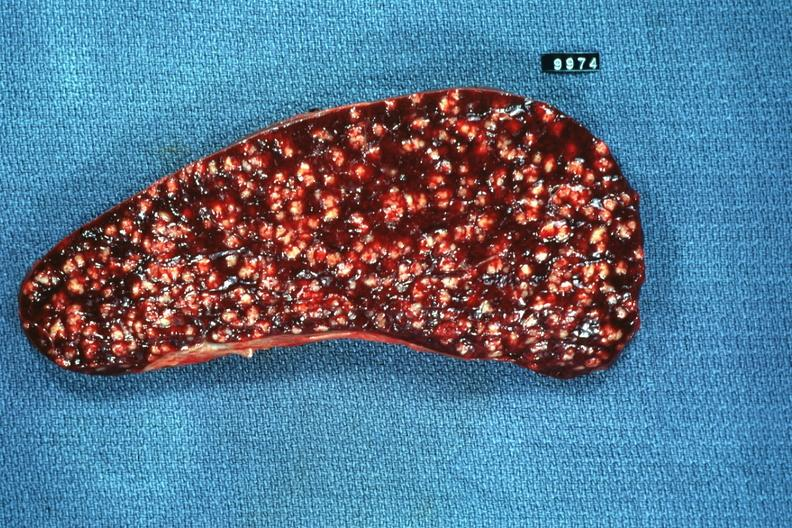s miliary tuberculosis present?
Answer the question using a single word or phrase. Yes 